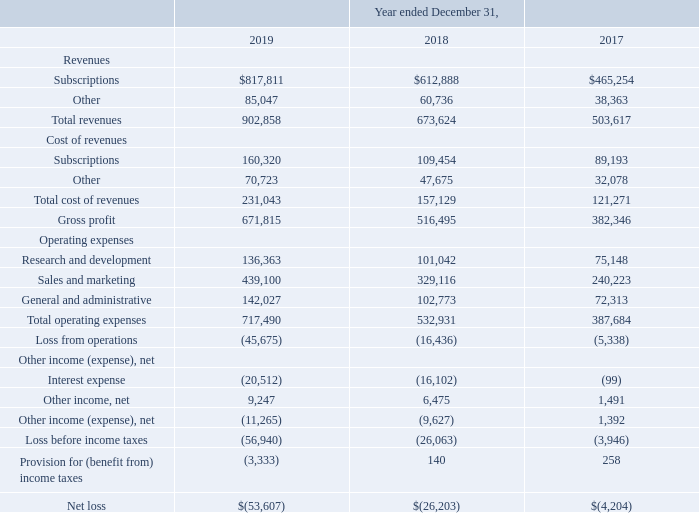Results of Operations
The following tables set forth selected consolidated statements of operations data and such data as a percentage of total revenues. The historical results presented below are not necessarily indicative of the results that may be expected for any future period (in thousands):
What are the respective subscription revenue in 2017, 2018 and 2019?
Answer scale should be: thousand. $465,254, $612,888, $817,811. What are the respective other revenue in 2017, 2018 and 2019?
Answer scale should be: thousand. 38,363, 60,736, 85,047. What are the respective total revenue in 2017, 2018 and 2019?
Answer scale should be: thousand. 503,617, 673,624, 902,858. What is the percentage change in subscription revenue between 2017 and 2018?
Answer scale should be: percent. (612,888 - 465,254)/465,254 
Answer: 31.73. What is the percentage change in total revenue between 2017 and 2018?
Answer scale should be: percent. (673,624 - 503,617)/503,617 
Answer: 33.76. What is the average other cost between 2017 to 2019?
Answer scale should be: thousand. (70,723 + 47,675 + 32,078)/3 
Answer: 50158.67. 